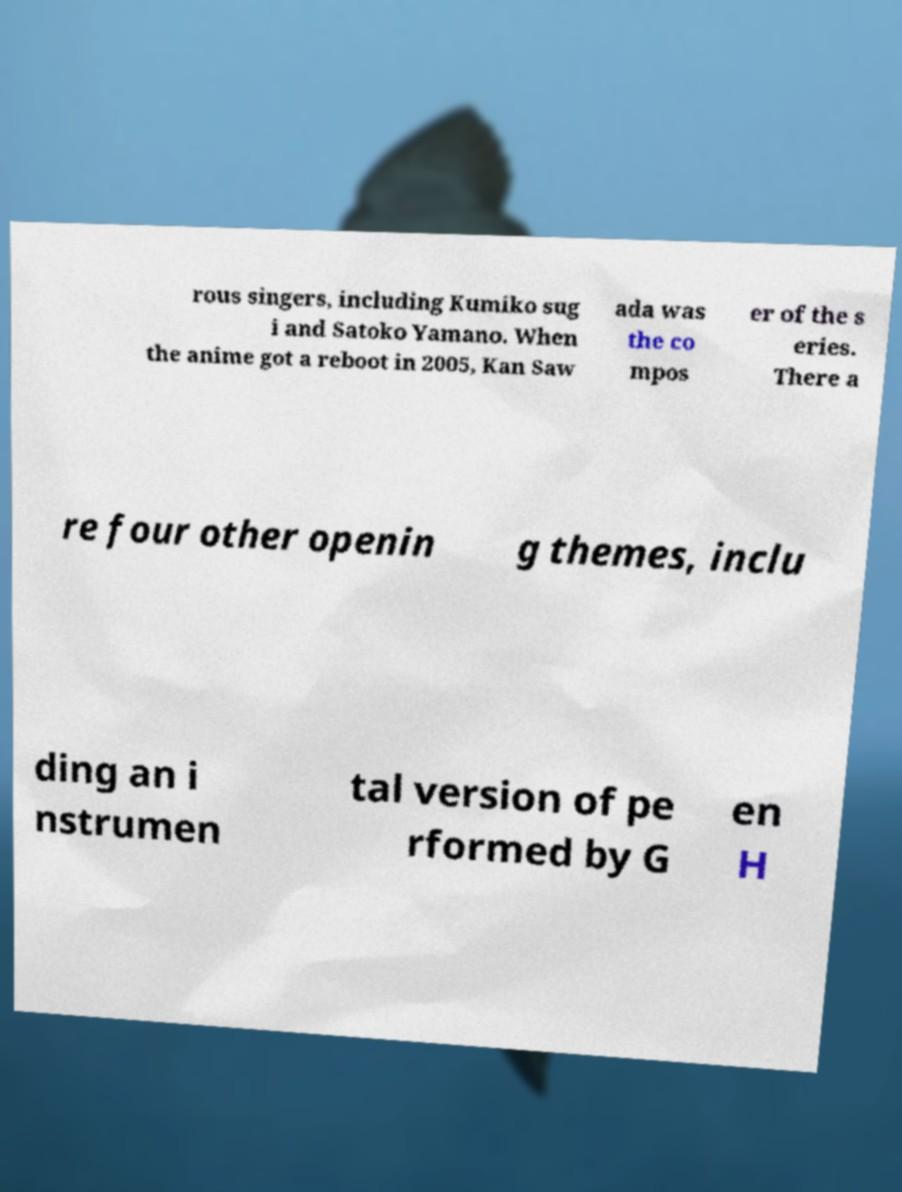Can you read and provide the text displayed in the image?This photo seems to have some interesting text. Can you extract and type it out for me? rous singers, including Kumiko sug i and Satoko Yamano. When the anime got a reboot in 2005, Kan Saw ada was the co mpos er of the s eries. There a re four other openin g themes, inclu ding an i nstrumen tal version of pe rformed by G en H 